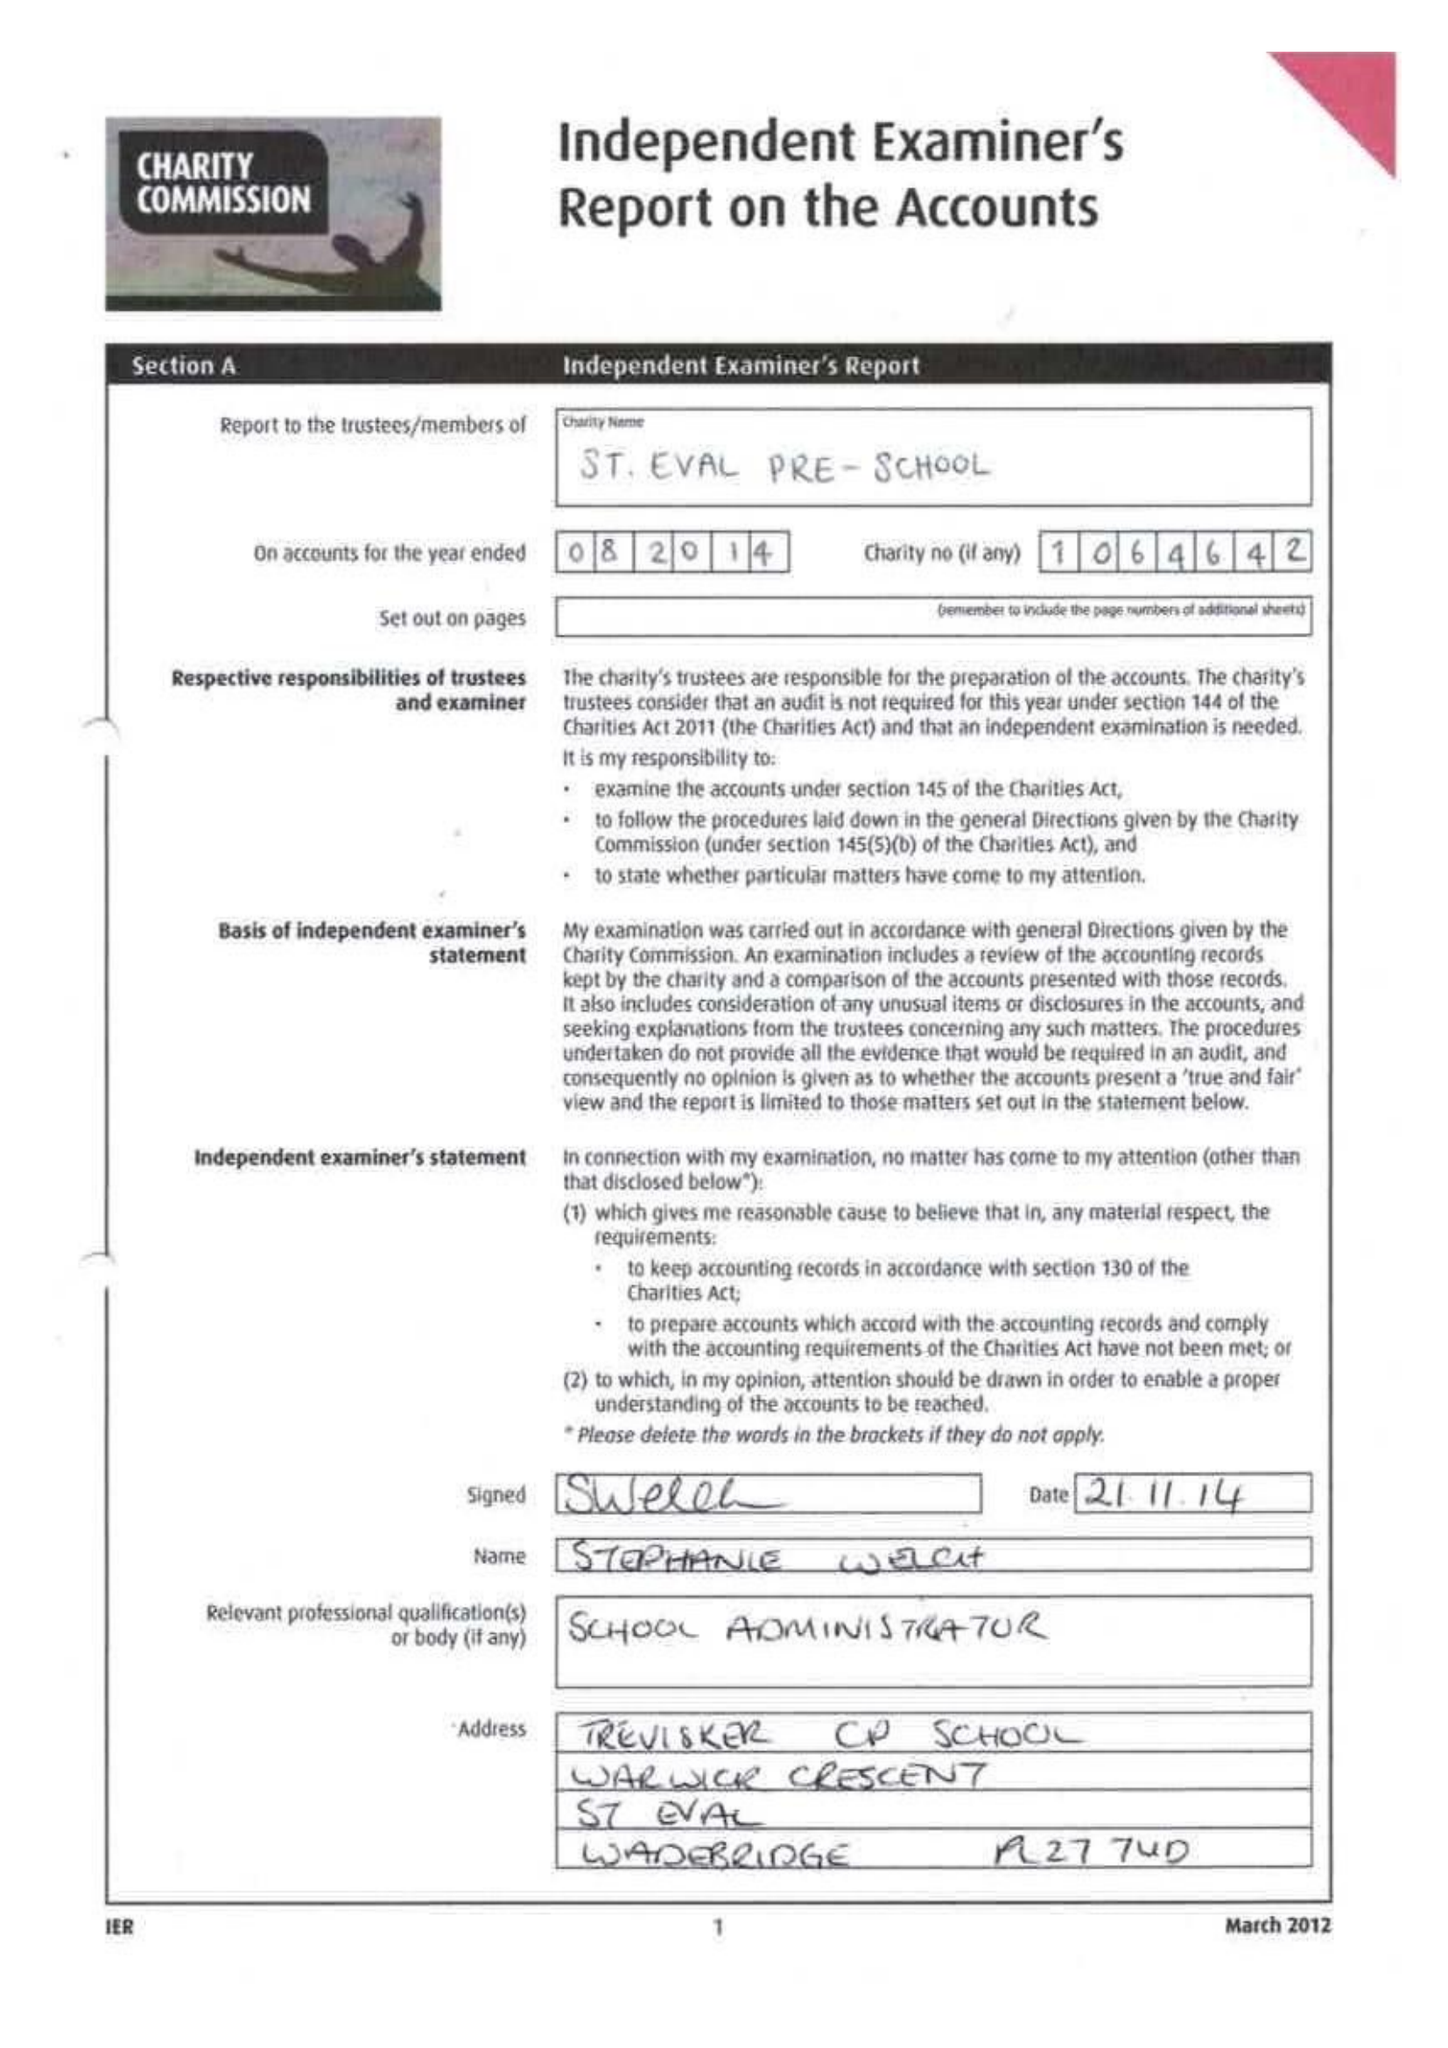What is the value for the charity_number?
Answer the question using a single word or phrase. 1064642 